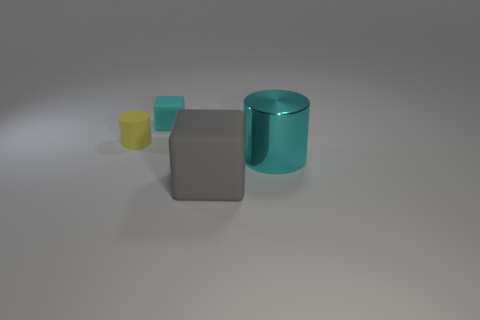Add 1 large gray cubes. How many objects exist? 5 Subtract all yellow cylinders. How many cylinders are left? 1 Subtract 1 cylinders. How many cylinders are left? 1 Add 4 blocks. How many blocks are left? 6 Add 4 rubber balls. How many rubber balls exist? 4 Subtract 0 brown balls. How many objects are left? 4 Subtract all blue cylinders. Subtract all yellow blocks. How many cylinders are left? 2 Subtract all brown matte cylinders. Subtract all matte blocks. How many objects are left? 2 